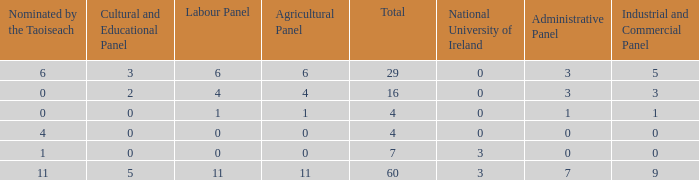What is the average nominated of the composition nominated by Taioseach with an Industrial and Commercial panel less than 9, an administrative panel greater than 0, a cultural and educational panel greater than 2, and a total less than 29? None. 